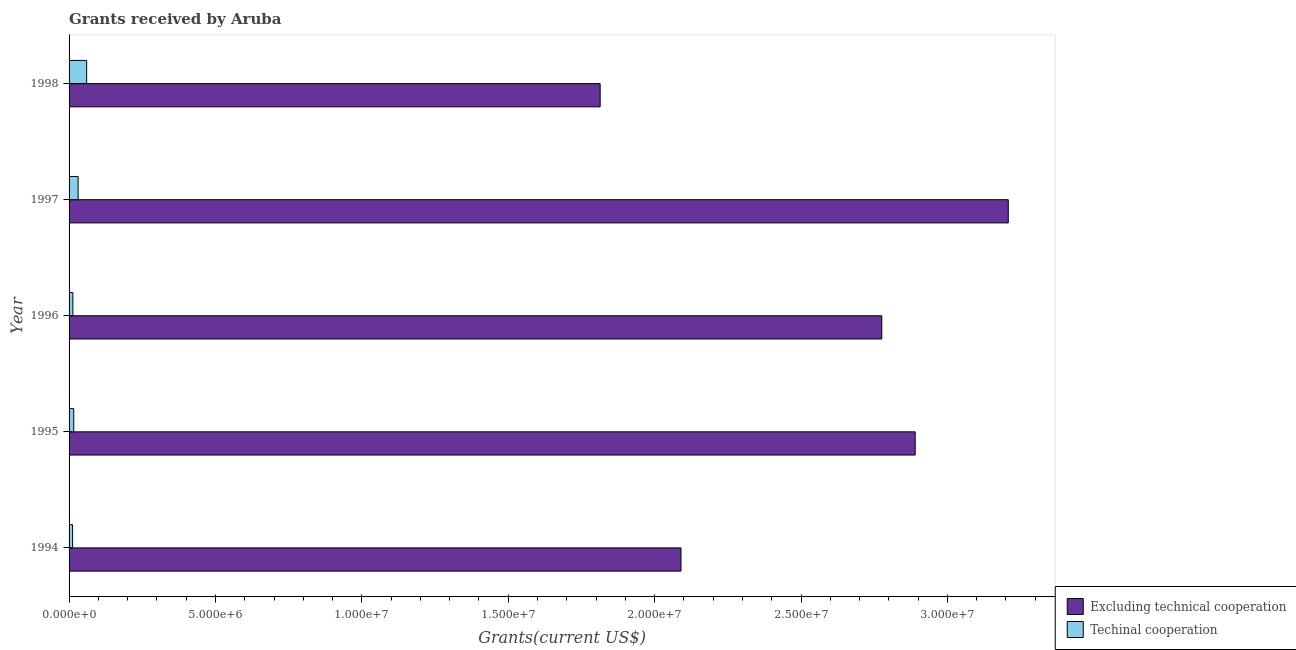How many different coloured bars are there?
Offer a very short reply. 2. How many bars are there on the 3rd tick from the top?
Offer a terse response. 2. How many bars are there on the 2nd tick from the bottom?
Your answer should be compact. 2. What is the label of the 1st group of bars from the top?
Ensure brevity in your answer.  1998. What is the amount of grants received(including technical cooperation) in 1994?
Offer a terse response. 1.20e+05. Across all years, what is the maximum amount of grants received(excluding technical cooperation)?
Provide a succinct answer. 3.21e+07. Across all years, what is the minimum amount of grants received(excluding technical cooperation)?
Ensure brevity in your answer.  1.81e+07. In which year was the amount of grants received(excluding technical cooperation) maximum?
Offer a very short reply. 1997. In which year was the amount of grants received(including technical cooperation) minimum?
Offer a terse response. 1994. What is the total amount of grants received(including technical cooperation) in the graph?
Provide a short and direct response. 1.32e+06. What is the difference between the amount of grants received(excluding technical cooperation) in 1997 and that in 1998?
Provide a succinct answer. 1.39e+07. What is the difference between the amount of grants received(excluding technical cooperation) in 1998 and the amount of grants received(including technical cooperation) in 1996?
Keep it short and to the point. 1.80e+07. What is the average amount of grants received(excluding technical cooperation) per year?
Ensure brevity in your answer.  2.56e+07. In the year 1995, what is the difference between the amount of grants received(including technical cooperation) and amount of grants received(excluding technical cooperation)?
Offer a very short reply. -2.87e+07. In how many years, is the amount of grants received(including technical cooperation) greater than 1000000 US$?
Provide a short and direct response. 0. What is the ratio of the amount of grants received(including technical cooperation) in 1995 to that in 1997?
Give a very brief answer. 0.52. Is the difference between the amount of grants received(including technical cooperation) in 1994 and 1997 greater than the difference between the amount of grants received(excluding technical cooperation) in 1994 and 1997?
Give a very brief answer. Yes. What is the difference between the highest and the second highest amount of grants received(including technical cooperation)?
Your response must be concise. 2.90e+05. What is the difference between the highest and the lowest amount of grants received(excluding technical cooperation)?
Keep it short and to the point. 1.39e+07. What does the 2nd bar from the top in 1994 represents?
Your response must be concise. Excluding technical cooperation. What does the 2nd bar from the bottom in 1998 represents?
Provide a short and direct response. Techinal cooperation. How many bars are there?
Offer a very short reply. 10. Are all the bars in the graph horizontal?
Provide a short and direct response. Yes. How many years are there in the graph?
Your response must be concise. 5. What is the difference between two consecutive major ticks on the X-axis?
Offer a very short reply. 5.00e+06. How many legend labels are there?
Offer a terse response. 2. How are the legend labels stacked?
Ensure brevity in your answer.  Vertical. What is the title of the graph?
Offer a very short reply. Grants received by Aruba. Does "current US$" appear as one of the legend labels in the graph?
Make the answer very short. No. What is the label or title of the X-axis?
Your answer should be very brief. Grants(current US$). What is the label or title of the Y-axis?
Make the answer very short. Year. What is the Grants(current US$) of Excluding technical cooperation in 1994?
Your answer should be very brief. 2.09e+07. What is the Grants(current US$) of Techinal cooperation in 1994?
Make the answer very short. 1.20e+05. What is the Grants(current US$) of Excluding technical cooperation in 1995?
Make the answer very short. 2.89e+07. What is the Grants(current US$) of Excluding technical cooperation in 1996?
Provide a succinct answer. 2.78e+07. What is the Grants(current US$) in Excluding technical cooperation in 1997?
Your answer should be compact. 3.21e+07. What is the Grants(current US$) of Excluding technical cooperation in 1998?
Provide a short and direct response. 1.81e+07. Across all years, what is the maximum Grants(current US$) in Excluding technical cooperation?
Provide a short and direct response. 3.21e+07. Across all years, what is the maximum Grants(current US$) in Techinal cooperation?
Your response must be concise. 6.00e+05. Across all years, what is the minimum Grants(current US$) of Excluding technical cooperation?
Provide a succinct answer. 1.81e+07. Across all years, what is the minimum Grants(current US$) in Techinal cooperation?
Your response must be concise. 1.20e+05. What is the total Grants(current US$) of Excluding technical cooperation in the graph?
Offer a very short reply. 1.28e+08. What is the total Grants(current US$) in Techinal cooperation in the graph?
Keep it short and to the point. 1.32e+06. What is the difference between the Grants(current US$) of Excluding technical cooperation in 1994 and that in 1995?
Make the answer very short. -8.00e+06. What is the difference between the Grants(current US$) of Techinal cooperation in 1994 and that in 1995?
Make the answer very short. -4.00e+04. What is the difference between the Grants(current US$) in Excluding technical cooperation in 1994 and that in 1996?
Provide a succinct answer. -6.86e+06. What is the difference between the Grants(current US$) in Excluding technical cooperation in 1994 and that in 1997?
Give a very brief answer. -1.12e+07. What is the difference between the Grants(current US$) in Excluding technical cooperation in 1994 and that in 1998?
Offer a very short reply. 2.76e+06. What is the difference between the Grants(current US$) of Techinal cooperation in 1994 and that in 1998?
Provide a short and direct response. -4.80e+05. What is the difference between the Grants(current US$) in Excluding technical cooperation in 1995 and that in 1996?
Provide a short and direct response. 1.14e+06. What is the difference between the Grants(current US$) in Techinal cooperation in 1995 and that in 1996?
Provide a short and direct response. 3.00e+04. What is the difference between the Grants(current US$) of Excluding technical cooperation in 1995 and that in 1997?
Offer a very short reply. -3.18e+06. What is the difference between the Grants(current US$) in Techinal cooperation in 1995 and that in 1997?
Make the answer very short. -1.50e+05. What is the difference between the Grants(current US$) of Excluding technical cooperation in 1995 and that in 1998?
Offer a very short reply. 1.08e+07. What is the difference between the Grants(current US$) of Techinal cooperation in 1995 and that in 1998?
Your response must be concise. -4.40e+05. What is the difference between the Grants(current US$) in Excluding technical cooperation in 1996 and that in 1997?
Make the answer very short. -4.32e+06. What is the difference between the Grants(current US$) in Excluding technical cooperation in 1996 and that in 1998?
Offer a very short reply. 9.62e+06. What is the difference between the Grants(current US$) in Techinal cooperation in 1996 and that in 1998?
Your response must be concise. -4.70e+05. What is the difference between the Grants(current US$) in Excluding technical cooperation in 1997 and that in 1998?
Keep it short and to the point. 1.39e+07. What is the difference between the Grants(current US$) in Excluding technical cooperation in 1994 and the Grants(current US$) in Techinal cooperation in 1995?
Your answer should be compact. 2.07e+07. What is the difference between the Grants(current US$) in Excluding technical cooperation in 1994 and the Grants(current US$) in Techinal cooperation in 1996?
Provide a short and direct response. 2.08e+07. What is the difference between the Grants(current US$) in Excluding technical cooperation in 1994 and the Grants(current US$) in Techinal cooperation in 1997?
Keep it short and to the point. 2.06e+07. What is the difference between the Grants(current US$) in Excluding technical cooperation in 1994 and the Grants(current US$) in Techinal cooperation in 1998?
Offer a terse response. 2.03e+07. What is the difference between the Grants(current US$) in Excluding technical cooperation in 1995 and the Grants(current US$) in Techinal cooperation in 1996?
Provide a short and direct response. 2.88e+07. What is the difference between the Grants(current US$) of Excluding technical cooperation in 1995 and the Grants(current US$) of Techinal cooperation in 1997?
Offer a terse response. 2.86e+07. What is the difference between the Grants(current US$) in Excluding technical cooperation in 1995 and the Grants(current US$) in Techinal cooperation in 1998?
Give a very brief answer. 2.83e+07. What is the difference between the Grants(current US$) in Excluding technical cooperation in 1996 and the Grants(current US$) in Techinal cooperation in 1997?
Provide a succinct answer. 2.74e+07. What is the difference between the Grants(current US$) in Excluding technical cooperation in 1996 and the Grants(current US$) in Techinal cooperation in 1998?
Your answer should be very brief. 2.72e+07. What is the difference between the Grants(current US$) of Excluding technical cooperation in 1997 and the Grants(current US$) of Techinal cooperation in 1998?
Provide a short and direct response. 3.15e+07. What is the average Grants(current US$) in Excluding technical cooperation per year?
Give a very brief answer. 2.56e+07. What is the average Grants(current US$) in Techinal cooperation per year?
Provide a succinct answer. 2.64e+05. In the year 1994, what is the difference between the Grants(current US$) in Excluding technical cooperation and Grants(current US$) in Techinal cooperation?
Offer a terse response. 2.08e+07. In the year 1995, what is the difference between the Grants(current US$) of Excluding technical cooperation and Grants(current US$) of Techinal cooperation?
Your answer should be compact. 2.87e+07. In the year 1996, what is the difference between the Grants(current US$) of Excluding technical cooperation and Grants(current US$) of Techinal cooperation?
Your answer should be compact. 2.76e+07. In the year 1997, what is the difference between the Grants(current US$) in Excluding technical cooperation and Grants(current US$) in Techinal cooperation?
Your answer should be very brief. 3.18e+07. In the year 1998, what is the difference between the Grants(current US$) of Excluding technical cooperation and Grants(current US$) of Techinal cooperation?
Offer a very short reply. 1.75e+07. What is the ratio of the Grants(current US$) of Excluding technical cooperation in 1994 to that in 1995?
Make the answer very short. 0.72. What is the ratio of the Grants(current US$) of Excluding technical cooperation in 1994 to that in 1996?
Provide a short and direct response. 0.75. What is the ratio of the Grants(current US$) of Techinal cooperation in 1994 to that in 1996?
Offer a terse response. 0.92. What is the ratio of the Grants(current US$) in Excluding technical cooperation in 1994 to that in 1997?
Ensure brevity in your answer.  0.65. What is the ratio of the Grants(current US$) of Techinal cooperation in 1994 to that in 1997?
Provide a succinct answer. 0.39. What is the ratio of the Grants(current US$) in Excluding technical cooperation in 1994 to that in 1998?
Ensure brevity in your answer.  1.15. What is the ratio of the Grants(current US$) of Techinal cooperation in 1994 to that in 1998?
Your response must be concise. 0.2. What is the ratio of the Grants(current US$) of Excluding technical cooperation in 1995 to that in 1996?
Keep it short and to the point. 1.04. What is the ratio of the Grants(current US$) in Techinal cooperation in 1995 to that in 1996?
Give a very brief answer. 1.23. What is the ratio of the Grants(current US$) in Excluding technical cooperation in 1995 to that in 1997?
Provide a short and direct response. 0.9. What is the ratio of the Grants(current US$) of Techinal cooperation in 1995 to that in 1997?
Your response must be concise. 0.52. What is the ratio of the Grants(current US$) in Excluding technical cooperation in 1995 to that in 1998?
Your answer should be compact. 1.59. What is the ratio of the Grants(current US$) of Techinal cooperation in 1995 to that in 1998?
Offer a terse response. 0.27. What is the ratio of the Grants(current US$) of Excluding technical cooperation in 1996 to that in 1997?
Ensure brevity in your answer.  0.87. What is the ratio of the Grants(current US$) in Techinal cooperation in 1996 to that in 1997?
Provide a succinct answer. 0.42. What is the ratio of the Grants(current US$) in Excluding technical cooperation in 1996 to that in 1998?
Provide a succinct answer. 1.53. What is the ratio of the Grants(current US$) in Techinal cooperation in 1996 to that in 1998?
Offer a very short reply. 0.22. What is the ratio of the Grants(current US$) in Excluding technical cooperation in 1997 to that in 1998?
Provide a short and direct response. 1.77. What is the ratio of the Grants(current US$) in Techinal cooperation in 1997 to that in 1998?
Your answer should be compact. 0.52. What is the difference between the highest and the second highest Grants(current US$) in Excluding technical cooperation?
Give a very brief answer. 3.18e+06. What is the difference between the highest and the lowest Grants(current US$) of Excluding technical cooperation?
Ensure brevity in your answer.  1.39e+07. 